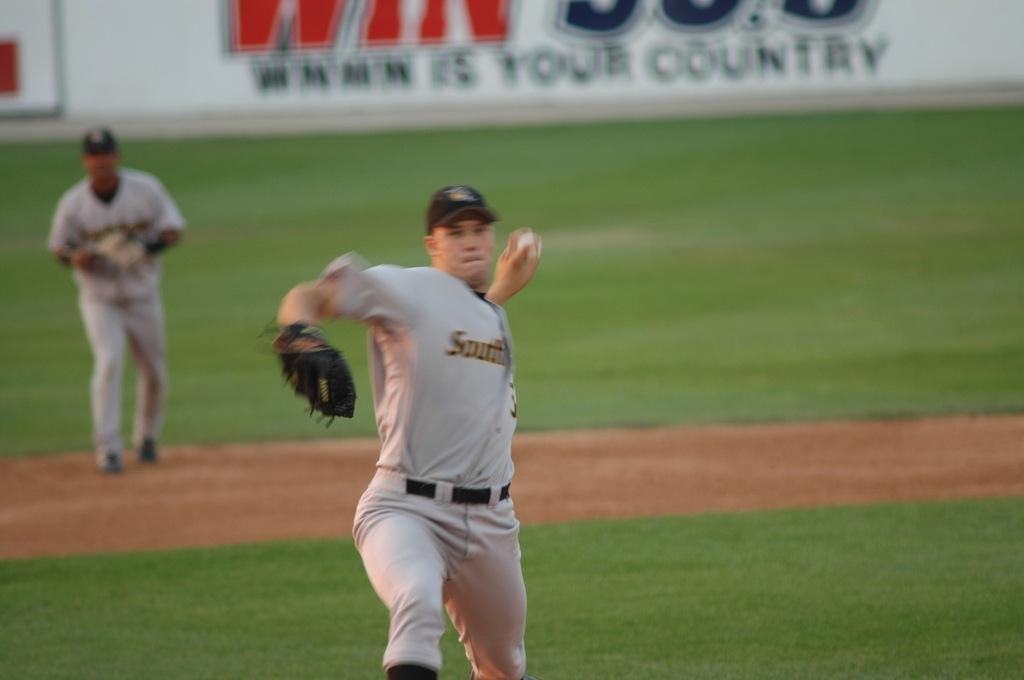<image>
Provide a brief description of the given image. South is written across one side of the pitcher's uniform as he throws the ball. 